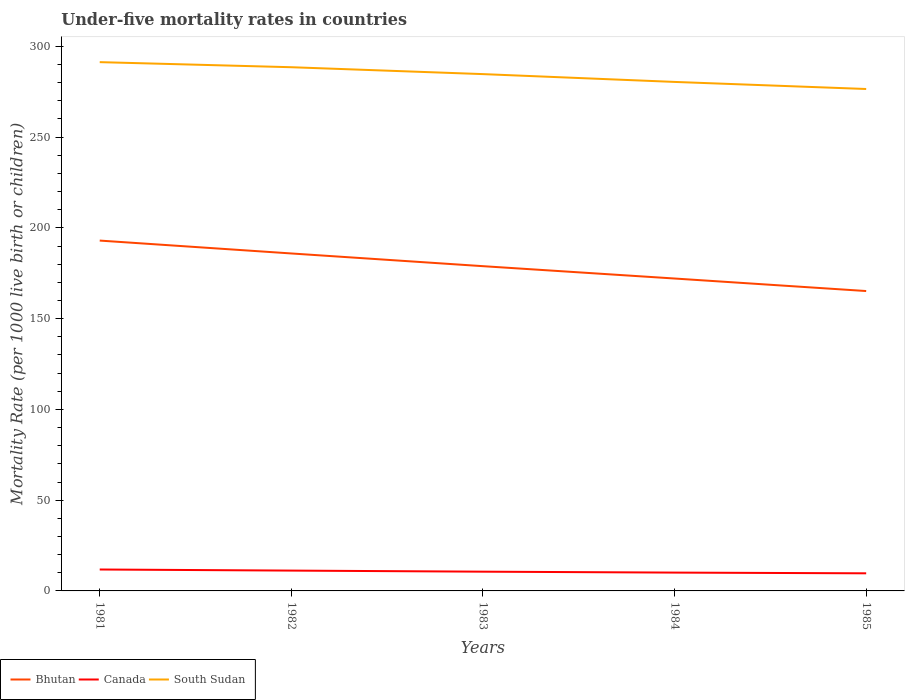How many different coloured lines are there?
Your response must be concise. 3. Does the line corresponding to Bhutan intersect with the line corresponding to Canada?
Give a very brief answer. No. Across all years, what is the maximum under-five mortality rate in Bhutan?
Offer a terse response. 165.2. What is the total under-five mortality rate in Canada in the graph?
Your response must be concise. 1.7. What is the difference between the highest and the second highest under-five mortality rate in Canada?
Ensure brevity in your answer.  2.1. What is the difference between the highest and the lowest under-five mortality rate in South Sudan?
Your response must be concise. 3. How many lines are there?
Provide a succinct answer. 3. What is the difference between two consecutive major ticks on the Y-axis?
Your answer should be compact. 50. Are the values on the major ticks of Y-axis written in scientific E-notation?
Provide a short and direct response. No. How many legend labels are there?
Offer a very short reply. 3. How are the legend labels stacked?
Offer a terse response. Horizontal. What is the title of the graph?
Ensure brevity in your answer.  Under-five mortality rates in countries. Does "Papua New Guinea" appear as one of the legend labels in the graph?
Provide a short and direct response. No. What is the label or title of the X-axis?
Ensure brevity in your answer.  Years. What is the label or title of the Y-axis?
Your answer should be very brief. Mortality Rate (per 1000 live birth or children). What is the Mortality Rate (per 1000 live birth or children) in Bhutan in 1981?
Offer a terse response. 193. What is the Mortality Rate (per 1000 live birth or children) in Canada in 1981?
Offer a very short reply. 11.8. What is the Mortality Rate (per 1000 live birth or children) in South Sudan in 1981?
Your answer should be very brief. 291.3. What is the Mortality Rate (per 1000 live birth or children) in Bhutan in 1982?
Offer a very short reply. 185.9. What is the Mortality Rate (per 1000 live birth or children) in South Sudan in 1982?
Offer a very short reply. 288.5. What is the Mortality Rate (per 1000 live birth or children) in Bhutan in 1983?
Make the answer very short. 178.9. What is the Mortality Rate (per 1000 live birth or children) of Canada in 1983?
Your response must be concise. 10.6. What is the Mortality Rate (per 1000 live birth or children) of South Sudan in 1983?
Your answer should be very brief. 284.7. What is the Mortality Rate (per 1000 live birth or children) of Bhutan in 1984?
Your answer should be very brief. 172.1. What is the Mortality Rate (per 1000 live birth or children) of Canada in 1984?
Provide a short and direct response. 10.1. What is the Mortality Rate (per 1000 live birth or children) in South Sudan in 1984?
Give a very brief answer. 280.4. What is the Mortality Rate (per 1000 live birth or children) of Bhutan in 1985?
Provide a succinct answer. 165.2. What is the Mortality Rate (per 1000 live birth or children) of Canada in 1985?
Your answer should be compact. 9.7. What is the Mortality Rate (per 1000 live birth or children) in South Sudan in 1985?
Provide a short and direct response. 276.5. Across all years, what is the maximum Mortality Rate (per 1000 live birth or children) of Bhutan?
Offer a terse response. 193. Across all years, what is the maximum Mortality Rate (per 1000 live birth or children) in Canada?
Your answer should be very brief. 11.8. Across all years, what is the maximum Mortality Rate (per 1000 live birth or children) of South Sudan?
Your response must be concise. 291.3. Across all years, what is the minimum Mortality Rate (per 1000 live birth or children) of Bhutan?
Your answer should be compact. 165.2. Across all years, what is the minimum Mortality Rate (per 1000 live birth or children) in Canada?
Your answer should be very brief. 9.7. Across all years, what is the minimum Mortality Rate (per 1000 live birth or children) in South Sudan?
Offer a terse response. 276.5. What is the total Mortality Rate (per 1000 live birth or children) of Bhutan in the graph?
Provide a succinct answer. 895.1. What is the total Mortality Rate (per 1000 live birth or children) of Canada in the graph?
Provide a short and direct response. 53.4. What is the total Mortality Rate (per 1000 live birth or children) in South Sudan in the graph?
Make the answer very short. 1421.4. What is the difference between the Mortality Rate (per 1000 live birth or children) in Canada in 1981 and that in 1982?
Make the answer very short. 0.6. What is the difference between the Mortality Rate (per 1000 live birth or children) in South Sudan in 1981 and that in 1982?
Make the answer very short. 2.8. What is the difference between the Mortality Rate (per 1000 live birth or children) in Bhutan in 1981 and that in 1983?
Your answer should be compact. 14.1. What is the difference between the Mortality Rate (per 1000 live birth or children) in South Sudan in 1981 and that in 1983?
Give a very brief answer. 6.6. What is the difference between the Mortality Rate (per 1000 live birth or children) in Bhutan in 1981 and that in 1984?
Provide a short and direct response. 20.9. What is the difference between the Mortality Rate (per 1000 live birth or children) in Canada in 1981 and that in 1984?
Ensure brevity in your answer.  1.7. What is the difference between the Mortality Rate (per 1000 live birth or children) in Bhutan in 1981 and that in 1985?
Offer a terse response. 27.8. What is the difference between the Mortality Rate (per 1000 live birth or children) in Canada in 1981 and that in 1985?
Provide a short and direct response. 2.1. What is the difference between the Mortality Rate (per 1000 live birth or children) of Bhutan in 1982 and that in 1983?
Offer a very short reply. 7. What is the difference between the Mortality Rate (per 1000 live birth or children) in Bhutan in 1982 and that in 1984?
Make the answer very short. 13.8. What is the difference between the Mortality Rate (per 1000 live birth or children) in Canada in 1982 and that in 1984?
Your response must be concise. 1.1. What is the difference between the Mortality Rate (per 1000 live birth or children) in South Sudan in 1982 and that in 1984?
Give a very brief answer. 8.1. What is the difference between the Mortality Rate (per 1000 live birth or children) in Bhutan in 1982 and that in 1985?
Provide a succinct answer. 20.7. What is the difference between the Mortality Rate (per 1000 live birth or children) of Canada in 1982 and that in 1985?
Offer a terse response. 1.5. What is the difference between the Mortality Rate (per 1000 live birth or children) of South Sudan in 1982 and that in 1985?
Make the answer very short. 12. What is the difference between the Mortality Rate (per 1000 live birth or children) of South Sudan in 1983 and that in 1984?
Offer a very short reply. 4.3. What is the difference between the Mortality Rate (per 1000 live birth or children) in Canada in 1983 and that in 1985?
Your answer should be compact. 0.9. What is the difference between the Mortality Rate (per 1000 live birth or children) of Bhutan in 1981 and the Mortality Rate (per 1000 live birth or children) of Canada in 1982?
Give a very brief answer. 181.8. What is the difference between the Mortality Rate (per 1000 live birth or children) of Bhutan in 1981 and the Mortality Rate (per 1000 live birth or children) of South Sudan in 1982?
Offer a very short reply. -95.5. What is the difference between the Mortality Rate (per 1000 live birth or children) in Canada in 1981 and the Mortality Rate (per 1000 live birth or children) in South Sudan in 1982?
Provide a short and direct response. -276.7. What is the difference between the Mortality Rate (per 1000 live birth or children) of Bhutan in 1981 and the Mortality Rate (per 1000 live birth or children) of Canada in 1983?
Provide a short and direct response. 182.4. What is the difference between the Mortality Rate (per 1000 live birth or children) in Bhutan in 1981 and the Mortality Rate (per 1000 live birth or children) in South Sudan in 1983?
Your answer should be compact. -91.7. What is the difference between the Mortality Rate (per 1000 live birth or children) of Canada in 1981 and the Mortality Rate (per 1000 live birth or children) of South Sudan in 1983?
Keep it short and to the point. -272.9. What is the difference between the Mortality Rate (per 1000 live birth or children) of Bhutan in 1981 and the Mortality Rate (per 1000 live birth or children) of Canada in 1984?
Provide a short and direct response. 182.9. What is the difference between the Mortality Rate (per 1000 live birth or children) in Bhutan in 1981 and the Mortality Rate (per 1000 live birth or children) in South Sudan in 1984?
Keep it short and to the point. -87.4. What is the difference between the Mortality Rate (per 1000 live birth or children) of Canada in 1981 and the Mortality Rate (per 1000 live birth or children) of South Sudan in 1984?
Make the answer very short. -268.6. What is the difference between the Mortality Rate (per 1000 live birth or children) in Bhutan in 1981 and the Mortality Rate (per 1000 live birth or children) in Canada in 1985?
Offer a terse response. 183.3. What is the difference between the Mortality Rate (per 1000 live birth or children) in Bhutan in 1981 and the Mortality Rate (per 1000 live birth or children) in South Sudan in 1985?
Provide a succinct answer. -83.5. What is the difference between the Mortality Rate (per 1000 live birth or children) in Canada in 1981 and the Mortality Rate (per 1000 live birth or children) in South Sudan in 1985?
Your answer should be compact. -264.7. What is the difference between the Mortality Rate (per 1000 live birth or children) of Bhutan in 1982 and the Mortality Rate (per 1000 live birth or children) of Canada in 1983?
Offer a terse response. 175.3. What is the difference between the Mortality Rate (per 1000 live birth or children) in Bhutan in 1982 and the Mortality Rate (per 1000 live birth or children) in South Sudan in 1983?
Provide a succinct answer. -98.8. What is the difference between the Mortality Rate (per 1000 live birth or children) of Canada in 1982 and the Mortality Rate (per 1000 live birth or children) of South Sudan in 1983?
Your answer should be very brief. -273.5. What is the difference between the Mortality Rate (per 1000 live birth or children) in Bhutan in 1982 and the Mortality Rate (per 1000 live birth or children) in Canada in 1984?
Your answer should be compact. 175.8. What is the difference between the Mortality Rate (per 1000 live birth or children) of Bhutan in 1982 and the Mortality Rate (per 1000 live birth or children) of South Sudan in 1984?
Offer a terse response. -94.5. What is the difference between the Mortality Rate (per 1000 live birth or children) in Canada in 1982 and the Mortality Rate (per 1000 live birth or children) in South Sudan in 1984?
Make the answer very short. -269.2. What is the difference between the Mortality Rate (per 1000 live birth or children) in Bhutan in 1982 and the Mortality Rate (per 1000 live birth or children) in Canada in 1985?
Give a very brief answer. 176.2. What is the difference between the Mortality Rate (per 1000 live birth or children) of Bhutan in 1982 and the Mortality Rate (per 1000 live birth or children) of South Sudan in 1985?
Provide a succinct answer. -90.6. What is the difference between the Mortality Rate (per 1000 live birth or children) in Canada in 1982 and the Mortality Rate (per 1000 live birth or children) in South Sudan in 1985?
Offer a very short reply. -265.3. What is the difference between the Mortality Rate (per 1000 live birth or children) of Bhutan in 1983 and the Mortality Rate (per 1000 live birth or children) of Canada in 1984?
Your answer should be compact. 168.8. What is the difference between the Mortality Rate (per 1000 live birth or children) in Bhutan in 1983 and the Mortality Rate (per 1000 live birth or children) in South Sudan in 1984?
Offer a very short reply. -101.5. What is the difference between the Mortality Rate (per 1000 live birth or children) in Canada in 1983 and the Mortality Rate (per 1000 live birth or children) in South Sudan in 1984?
Ensure brevity in your answer.  -269.8. What is the difference between the Mortality Rate (per 1000 live birth or children) in Bhutan in 1983 and the Mortality Rate (per 1000 live birth or children) in Canada in 1985?
Make the answer very short. 169.2. What is the difference between the Mortality Rate (per 1000 live birth or children) in Bhutan in 1983 and the Mortality Rate (per 1000 live birth or children) in South Sudan in 1985?
Keep it short and to the point. -97.6. What is the difference between the Mortality Rate (per 1000 live birth or children) of Canada in 1983 and the Mortality Rate (per 1000 live birth or children) of South Sudan in 1985?
Provide a short and direct response. -265.9. What is the difference between the Mortality Rate (per 1000 live birth or children) in Bhutan in 1984 and the Mortality Rate (per 1000 live birth or children) in Canada in 1985?
Make the answer very short. 162.4. What is the difference between the Mortality Rate (per 1000 live birth or children) of Bhutan in 1984 and the Mortality Rate (per 1000 live birth or children) of South Sudan in 1985?
Provide a short and direct response. -104.4. What is the difference between the Mortality Rate (per 1000 live birth or children) of Canada in 1984 and the Mortality Rate (per 1000 live birth or children) of South Sudan in 1985?
Make the answer very short. -266.4. What is the average Mortality Rate (per 1000 live birth or children) in Bhutan per year?
Your response must be concise. 179.02. What is the average Mortality Rate (per 1000 live birth or children) of Canada per year?
Offer a terse response. 10.68. What is the average Mortality Rate (per 1000 live birth or children) in South Sudan per year?
Give a very brief answer. 284.28. In the year 1981, what is the difference between the Mortality Rate (per 1000 live birth or children) of Bhutan and Mortality Rate (per 1000 live birth or children) of Canada?
Your response must be concise. 181.2. In the year 1981, what is the difference between the Mortality Rate (per 1000 live birth or children) of Bhutan and Mortality Rate (per 1000 live birth or children) of South Sudan?
Ensure brevity in your answer.  -98.3. In the year 1981, what is the difference between the Mortality Rate (per 1000 live birth or children) of Canada and Mortality Rate (per 1000 live birth or children) of South Sudan?
Keep it short and to the point. -279.5. In the year 1982, what is the difference between the Mortality Rate (per 1000 live birth or children) of Bhutan and Mortality Rate (per 1000 live birth or children) of Canada?
Your response must be concise. 174.7. In the year 1982, what is the difference between the Mortality Rate (per 1000 live birth or children) in Bhutan and Mortality Rate (per 1000 live birth or children) in South Sudan?
Your response must be concise. -102.6. In the year 1982, what is the difference between the Mortality Rate (per 1000 live birth or children) in Canada and Mortality Rate (per 1000 live birth or children) in South Sudan?
Provide a short and direct response. -277.3. In the year 1983, what is the difference between the Mortality Rate (per 1000 live birth or children) in Bhutan and Mortality Rate (per 1000 live birth or children) in Canada?
Give a very brief answer. 168.3. In the year 1983, what is the difference between the Mortality Rate (per 1000 live birth or children) in Bhutan and Mortality Rate (per 1000 live birth or children) in South Sudan?
Offer a very short reply. -105.8. In the year 1983, what is the difference between the Mortality Rate (per 1000 live birth or children) in Canada and Mortality Rate (per 1000 live birth or children) in South Sudan?
Your response must be concise. -274.1. In the year 1984, what is the difference between the Mortality Rate (per 1000 live birth or children) in Bhutan and Mortality Rate (per 1000 live birth or children) in Canada?
Provide a succinct answer. 162. In the year 1984, what is the difference between the Mortality Rate (per 1000 live birth or children) in Bhutan and Mortality Rate (per 1000 live birth or children) in South Sudan?
Make the answer very short. -108.3. In the year 1984, what is the difference between the Mortality Rate (per 1000 live birth or children) of Canada and Mortality Rate (per 1000 live birth or children) of South Sudan?
Your answer should be compact. -270.3. In the year 1985, what is the difference between the Mortality Rate (per 1000 live birth or children) of Bhutan and Mortality Rate (per 1000 live birth or children) of Canada?
Offer a very short reply. 155.5. In the year 1985, what is the difference between the Mortality Rate (per 1000 live birth or children) of Bhutan and Mortality Rate (per 1000 live birth or children) of South Sudan?
Provide a short and direct response. -111.3. In the year 1985, what is the difference between the Mortality Rate (per 1000 live birth or children) in Canada and Mortality Rate (per 1000 live birth or children) in South Sudan?
Offer a terse response. -266.8. What is the ratio of the Mortality Rate (per 1000 live birth or children) of Bhutan in 1981 to that in 1982?
Give a very brief answer. 1.04. What is the ratio of the Mortality Rate (per 1000 live birth or children) of Canada in 1981 to that in 1982?
Ensure brevity in your answer.  1.05. What is the ratio of the Mortality Rate (per 1000 live birth or children) of South Sudan in 1981 to that in 1982?
Keep it short and to the point. 1.01. What is the ratio of the Mortality Rate (per 1000 live birth or children) in Bhutan in 1981 to that in 1983?
Your answer should be very brief. 1.08. What is the ratio of the Mortality Rate (per 1000 live birth or children) of Canada in 1981 to that in 1983?
Give a very brief answer. 1.11. What is the ratio of the Mortality Rate (per 1000 live birth or children) of South Sudan in 1981 to that in 1983?
Provide a short and direct response. 1.02. What is the ratio of the Mortality Rate (per 1000 live birth or children) in Bhutan in 1981 to that in 1984?
Ensure brevity in your answer.  1.12. What is the ratio of the Mortality Rate (per 1000 live birth or children) of Canada in 1981 to that in 1984?
Give a very brief answer. 1.17. What is the ratio of the Mortality Rate (per 1000 live birth or children) of South Sudan in 1981 to that in 1984?
Provide a succinct answer. 1.04. What is the ratio of the Mortality Rate (per 1000 live birth or children) of Bhutan in 1981 to that in 1985?
Offer a terse response. 1.17. What is the ratio of the Mortality Rate (per 1000 live birth or children) in Canada in 1981 to that in 1985?
Provide a succinct answer. 1.22. What is the ratio of the Mortality Rate (per 1000 live birth or children) of South Sudan in 1981 to that in 1985?
Your answer should be compact. 1.05. What is the ratio of the Mortality Rate (per 1000 live birth or children) in Bhutan in 1982 to that in 1983?
Your answer should be very brief. 1.04. What is the ratio of the Mortality Rate (per 1000 live birth or children) of Canada in 1982 to that in 1983?
Your answer should be compact. 1.06. What is the ratio of the Mortality Rate (per 1000 live birth or children) of South Sudan in 1982 to that in 1983?
Give a very brief answer. 1.01. What is the ratio of the Mortality Rate (per 1000 live birth or children) in Bhutan in 1982 to that in 1984?
Ensure brevity in your answer.  1.08. What is the ratio of the Mortality Rate (per 1000 live birth or children) of Canada in 1982 to that in 1984?
Give a very brief answer. 1.11. What is the ratio of the Mortality Rate (per 1000 live birth or children) of South Sudan in 1982 to that in 1984?
Your answer should be compact. 1.03. What is the ratio of the Mortality Rate (per 1000 live birth or children) in Bhutan in 1982 to that in 1985?
Make the answer very short. 1.13. What is the ratio of the Mortality Rate (per 1000 live birth or children) in Canada in 1982 to that in 1985?
Provide a short and direct response. 1.15. What is the ratio of the Mortality Rate (per 1000 live birth or children) in South Sudan in 1982 to that in 1985?
Provide a succinct answer. 1.04. What is the ratio of the Mortality Rate (per 1000 live birth or children) of Bhutan in 1983 to that in 1984?
Provide a short and direct response. 1.04. What is the ratio of the Mortality Rate (per 1000 live birth or children) in Canada in 1983 to that in 1984?
Ensure brevity in your answer.  1.05. What is the ratio of the Mortality Rate (per 1000 live birth or children) of South Sudan in 1983 to that in 1984?
Make the answer very short. 1.02. What is the ratio of the Mortality Rate (per 1000 live birth or children) of Bhutan in 1983 to that in 1985?
Your answer should be very brief. 1.08. What is the ratio of the Mortality Rate (per 1000 live birth or children) in Canada in 1983 to that in 1985?
Your answer should be compact. 1.09. What is the ratio of the Mortality Rate (per 1000 live birth or children) of South Sudan in 1983 to that in 1985?
Offer a very short reply. 1.03. What is the ratio of the Mortality Rate (per 1000 live birth or children) of Bhutan in 1984 to that in 1985?
Your response must be concise. 1.04. What is the ratio of the Mortality Rate (per 1000 live birth or children) in Canada in 1984 to that in 1985?
Provide a short and direct response. 1.04. What is the ratio of the Mortality Rate (per 1000 live birth or children) in South Sudan in 1984 to that in 1985?
Offer a terse response. 1.01. What is the difference between the highest and the lowest Mortality Rate (per 1000 live birth or children) in Bhutan?
Make the answer very short. 27.8. What is the difference between the highest and the lowest Mortality Rate (per 1000 live birth or children) of South Sudan?
Your answer should be very brief. 14.8. 